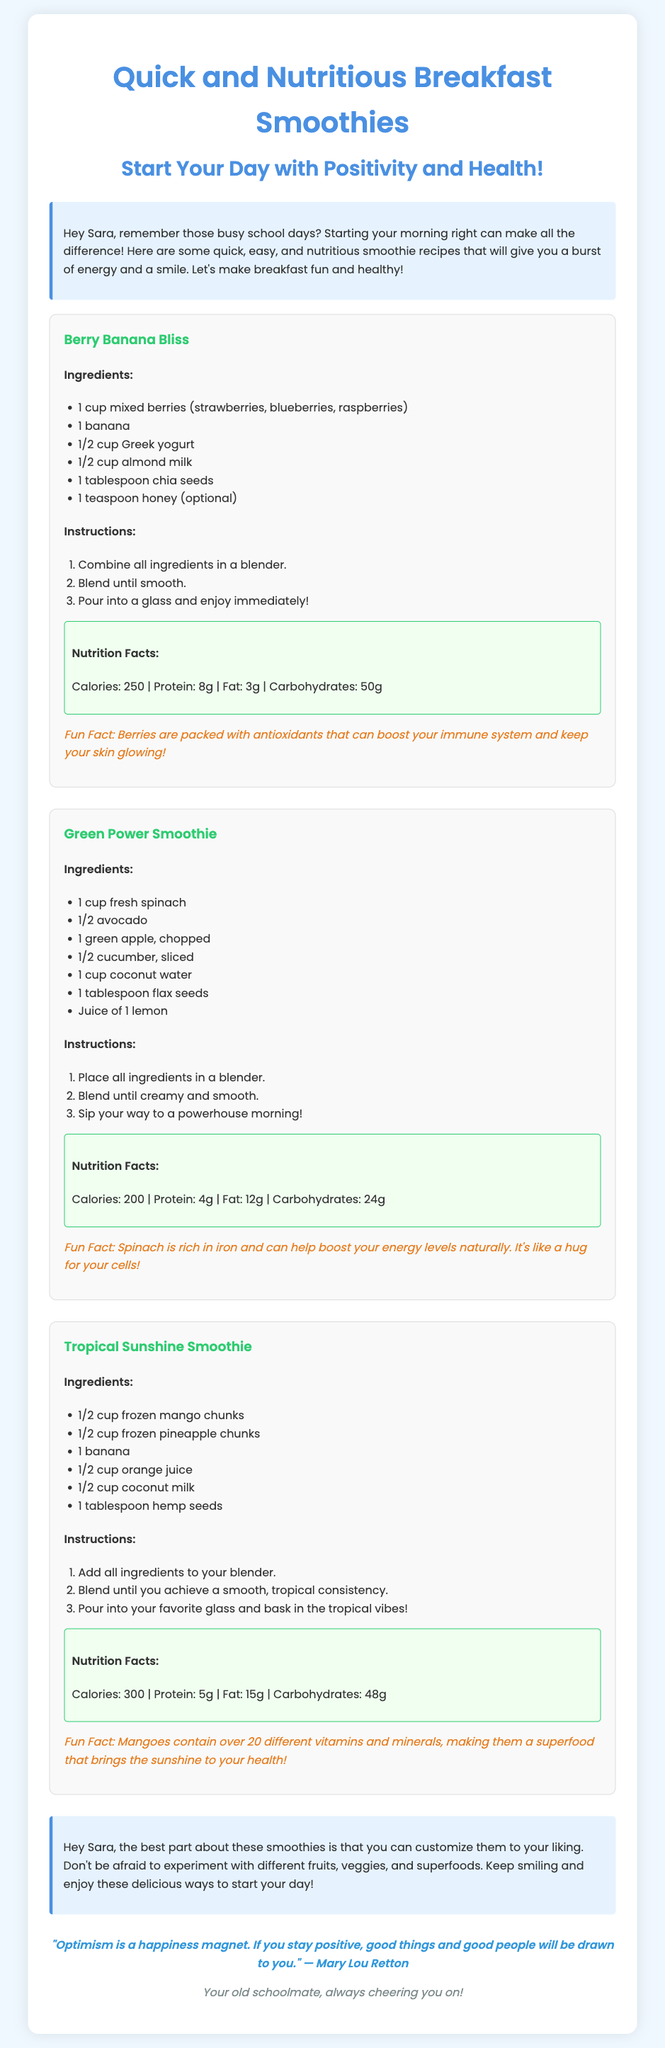what is the first smoothie recipe listed? The first recipe mentioned in the card is the "Berry Banana Bliss."
Answer: Berry Banana Bliss how much almond milk is needed for the Berry Banana Bliss? The recipe for Berry Banana Bliss specifies 1/2 cup of almond milk.
Answer: 1/2 cup what is a fun fact about berries? The document states that berries are packed with antioxidants that can boost your immune system and keep your skin glowing.
Answer: Antioxidants boost your immune system and skin glow how many calories are in the Tropical Sunshine Smoothie? The Tropical Sunshine Smoothie contains 300 calories as stated in the nutrition facts.
Answer: 300 how can you customize the smoothies? The friendly advice in the document suggests that you can experiment with different fruits, veggies, and superfoods.
Answer: Experiment with different fruits, veggies, and superfoods what is the main ingredient that provides creaminess in the Green Power Smoothie? The main ingredient contributing to the creaminess in the Green Power Smoothie is avocado.
Answer: Avocado how many different vitamins and minerals are in mangoes? The document mentions mangoes contain over 20 different vitamins and minerals.
Answer: Over 20 what is the total amount of protein in the Berry Banana Bliss and Green Power Smoothie combined? The Berry Banana Bliss contains 8g of protein and the Green Power Smoothie contains 4g, totaling 12g of protein.
Answer: 12g 